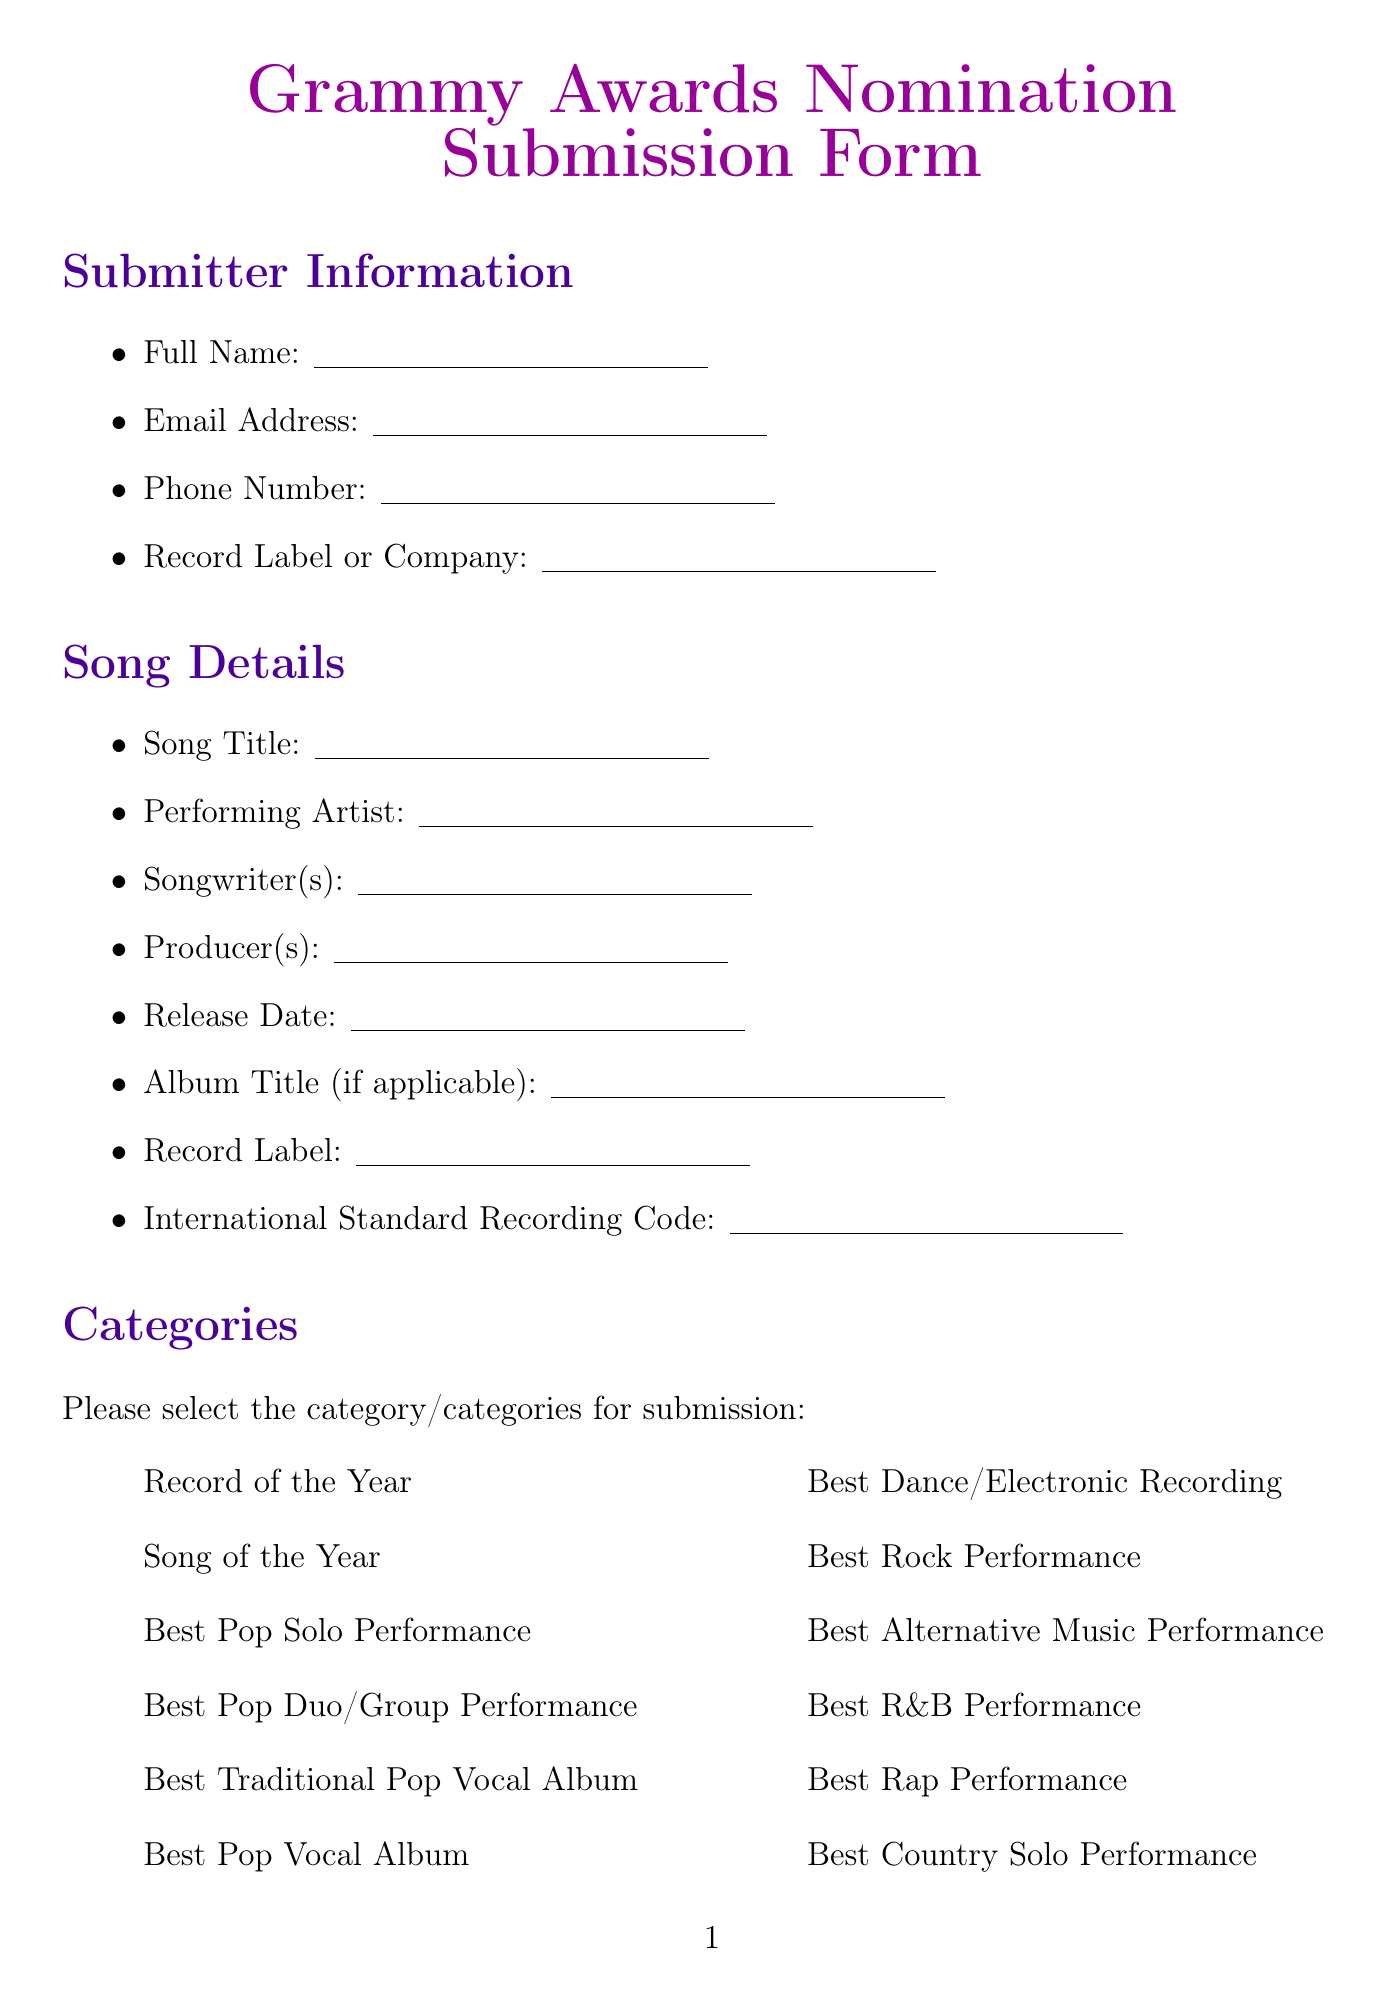what is the title of the song? The title of the song is indicated in the "Song Title" field under Song Details.
Answer: Song Title who is the performing artist? The performing artist is mentioned in the "Performing Artist" field under Song Details.
Answer: Performing Artist when was the song released? The release date is specified in the "Release Date" field under Song Details.
Answer: Release Date which category can be selected for submission? The categories for submission are provided in the "Categories" section of the document.
Answer: Various options (e.g., Record of the Year, Song of the Year) what is the primary genre of the song? The primary genre is to be entered in the "Primary Genre" field under Additional Information.
Answer: Primary Genre who are the featured artists? Featured artists (if any) are listed in the "Featured Artists" field under Collaborators.
Answer: Featured Artists what is included in the declaration section? The declaration section contains statements regarding rights ownership and accuracy of information.
Answer: Rights and accuracy confirmations how many lyrical themes can be selected? The document provides a list of lyrical themes from which multiple choices can be made.
Answer: Multiple themes (up to 8 options) what is the audio format specified? Audio format can be filled out in the "Audio Format" field under Technical Specifications.
Answer: Audio Format what needs to be confirmed regarding rights ownership? The submitter needs to confirm their right to submit the song for Grammy consideration in the Declaration.
Answer: Rights ownership confirmation 